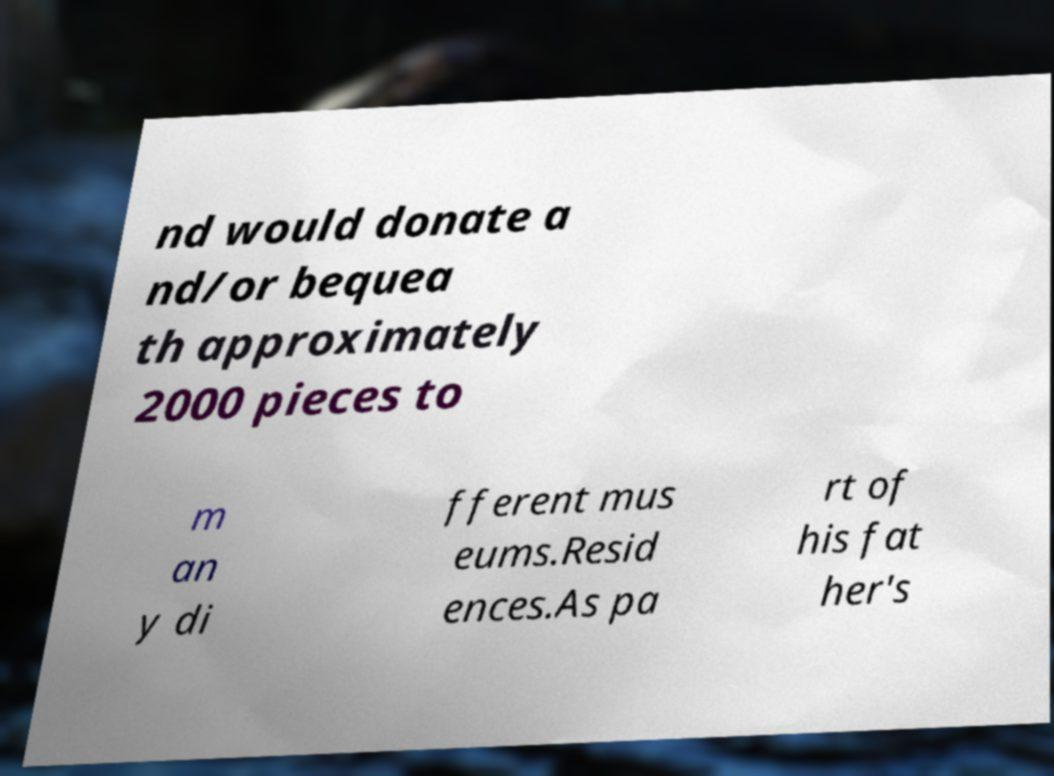Please identify and transcribe the text found in this image. nd would donate a nd/or bequea th approximately 2000 pieces to m an y di fferent mus eums.Resid ences.As pa rt of his fat her's 